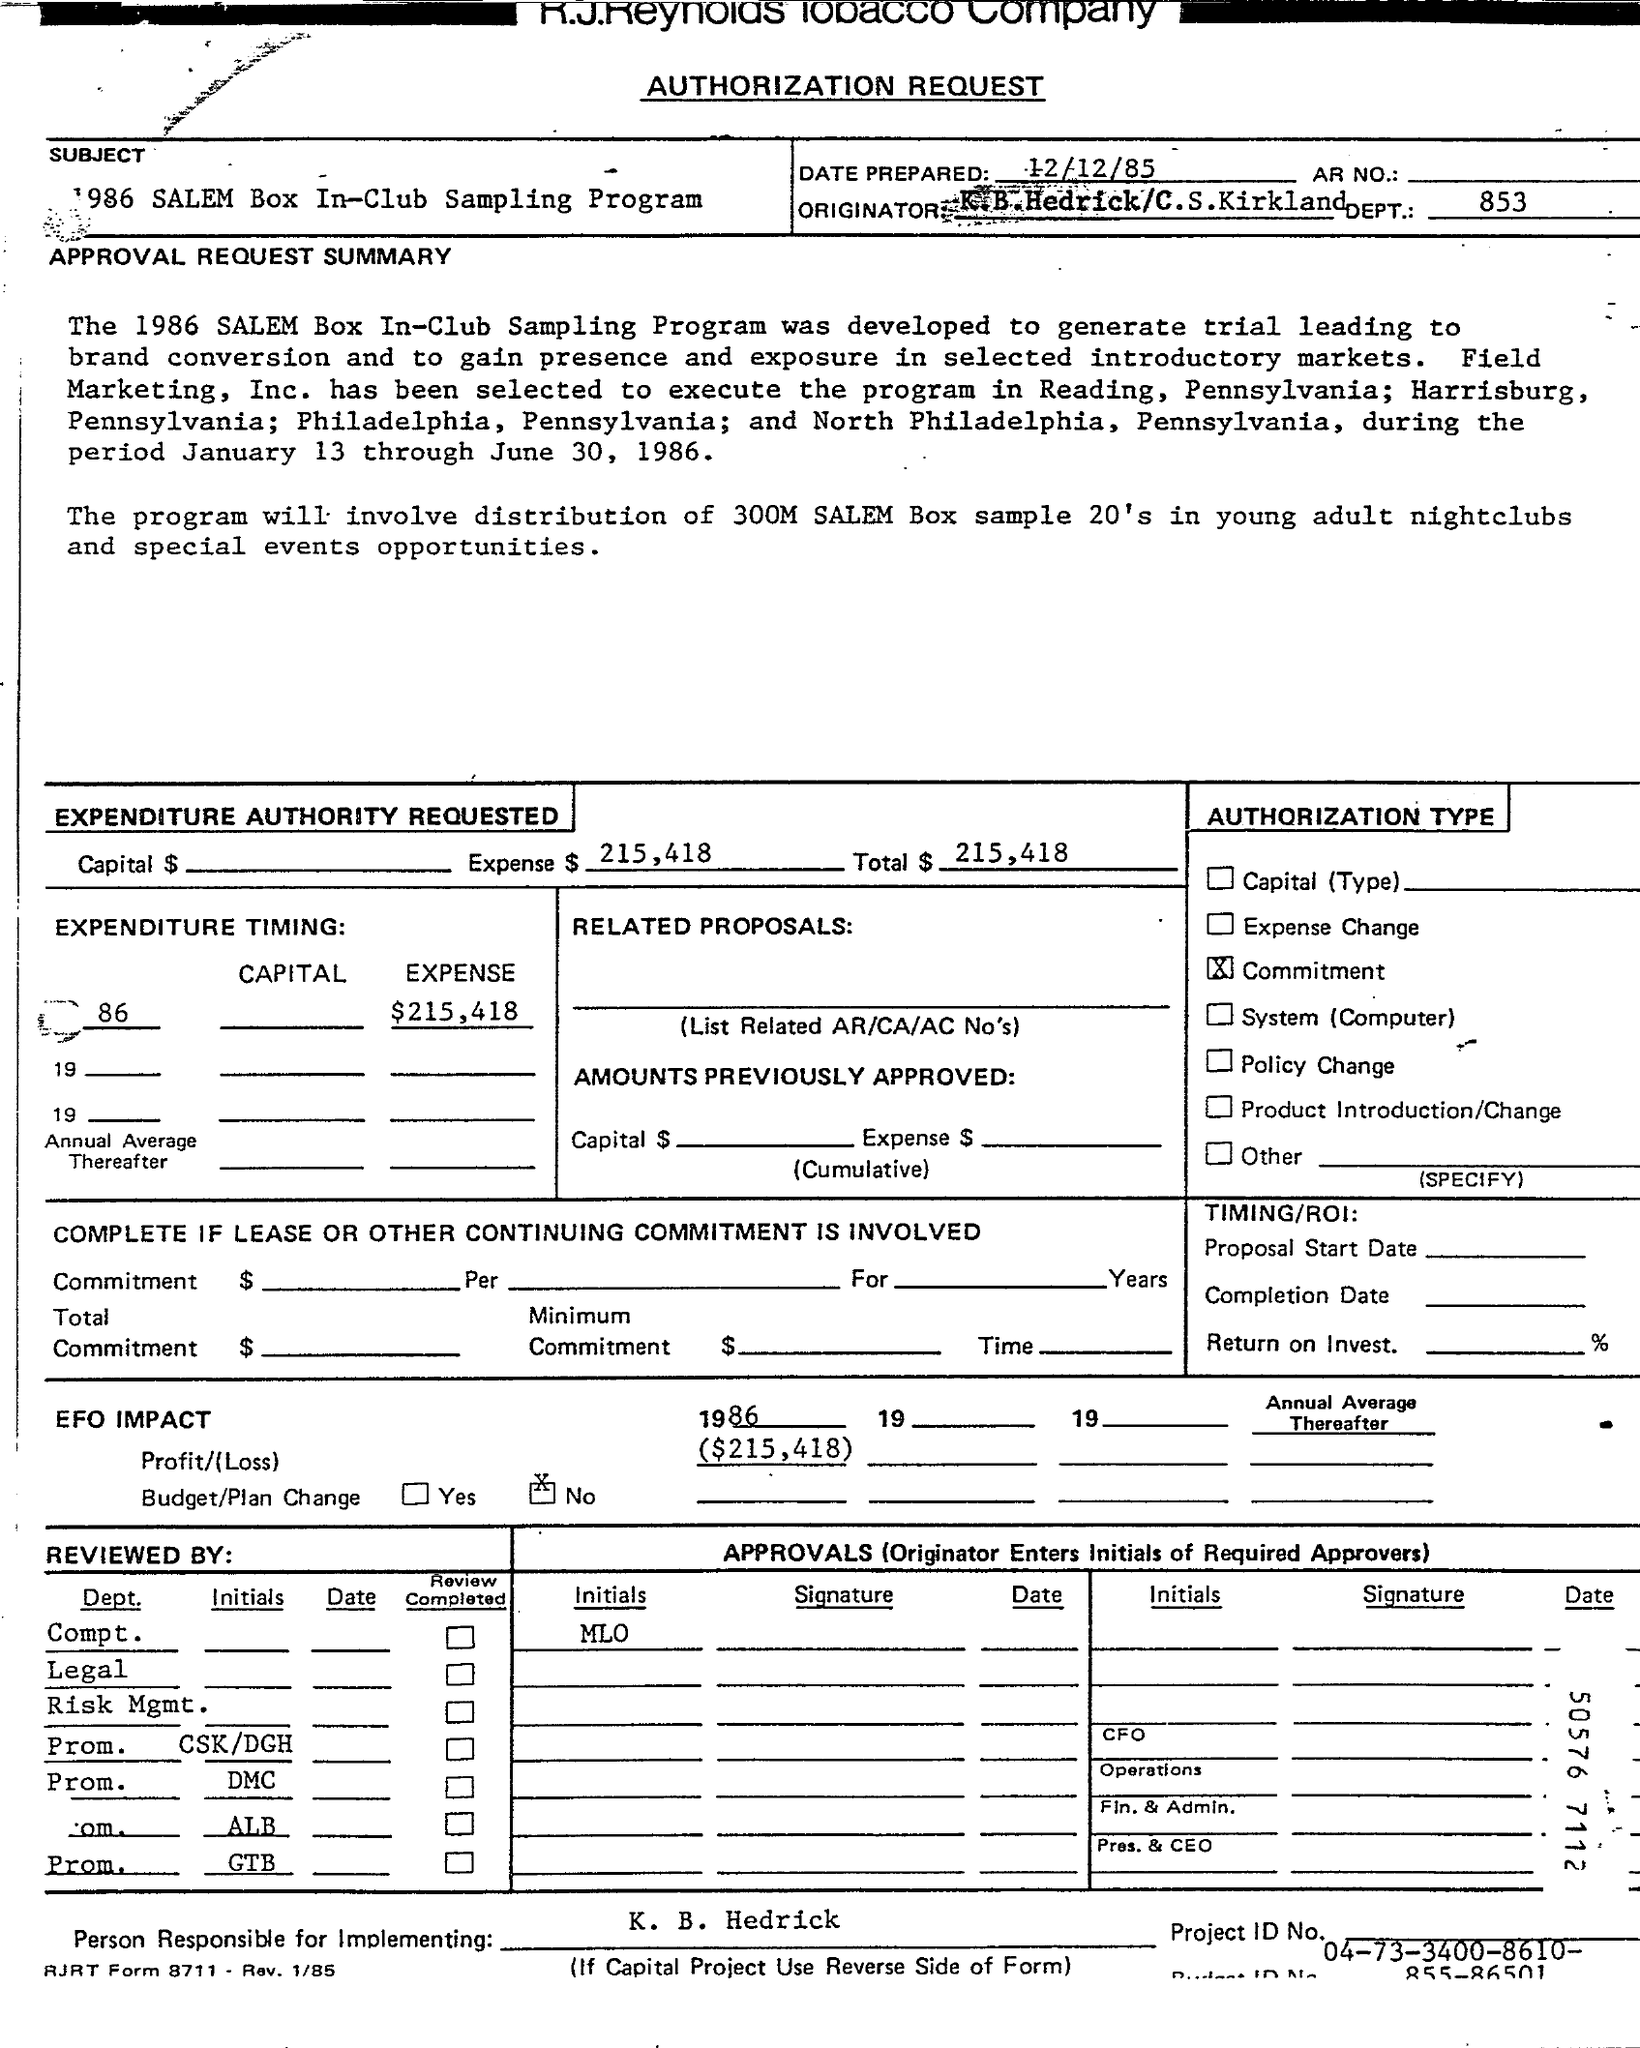Give some essential details in this illustration. The expense amount is $215,418. K. B. Hedrick is the person responsible for implementing. On what date was the document prepared? The total amount is 215,418. The title of the document is an authorization request. 